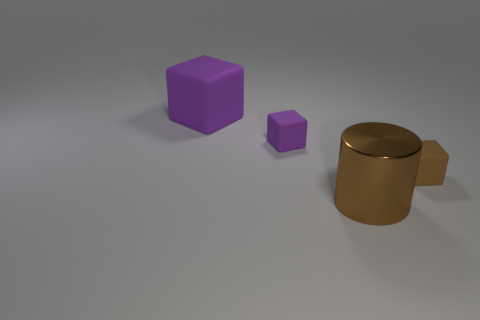Add 1 large shiny objects. How many objects exist? 5 Subtract all cylinders. How many objects are left? 3 Subtract 0 green blocks. How many objects are left? 4 Subtract all purple objects. Subtract all brown metal cylinders. How many objects are left? 1 Add 1 big shiny objects. How many big shiny objects are left? 2 Add 3 red cylinders. How many red cylinders exist? 3 